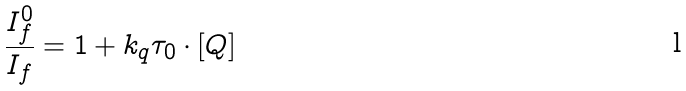<formula> <loc_0><loc_0><loc_500><loc_500>\frac { I _ { f } ^ { 0 } } { I _ { f } } = 1 + k _ { q } \tau _ { 0 } \cdot [ Q ]</formula> 